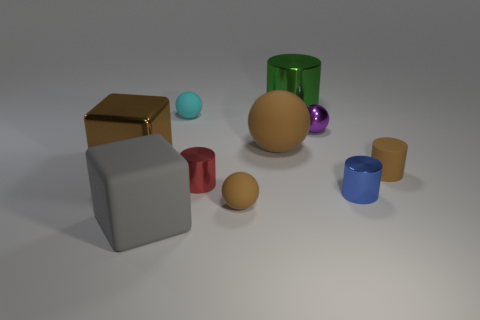What is the shape of the small brown rubber thing that is to the left of the small brown rubber cylinder right of the blue object?
Provide a short and direct response. Sphere. What is the size of the cube in front of the tiny rubber cylinder?
Give a very brief answer. Large. Is the small blue object made of the same material as the small cyan sphere?
Offer a very short reply. No. There is a large brown thing that is made of the same material as the brown cylinder; what is its shape?
Keep it short and to the point. Sphere. Is there anything else of the same color as the big cylinder?
Keep it short and to the point. No. The tiny matte ball to the right of the red shiny object is what color?
Keep it short and to the point. Brown. There is a large metal object in front of the big green metal object; is its color the same as the small matte cylinder?
Offer a terse response. Yes. What material is the large brown thing that is the same shape as the tiny purple thing?
Provide a succinct answer. Rubber. What number of brown things are the same size as the gray matte block?
Ensure brevity in your answer.  2. The small cyan object is what shape?
Offer a terse response. Sphere. 